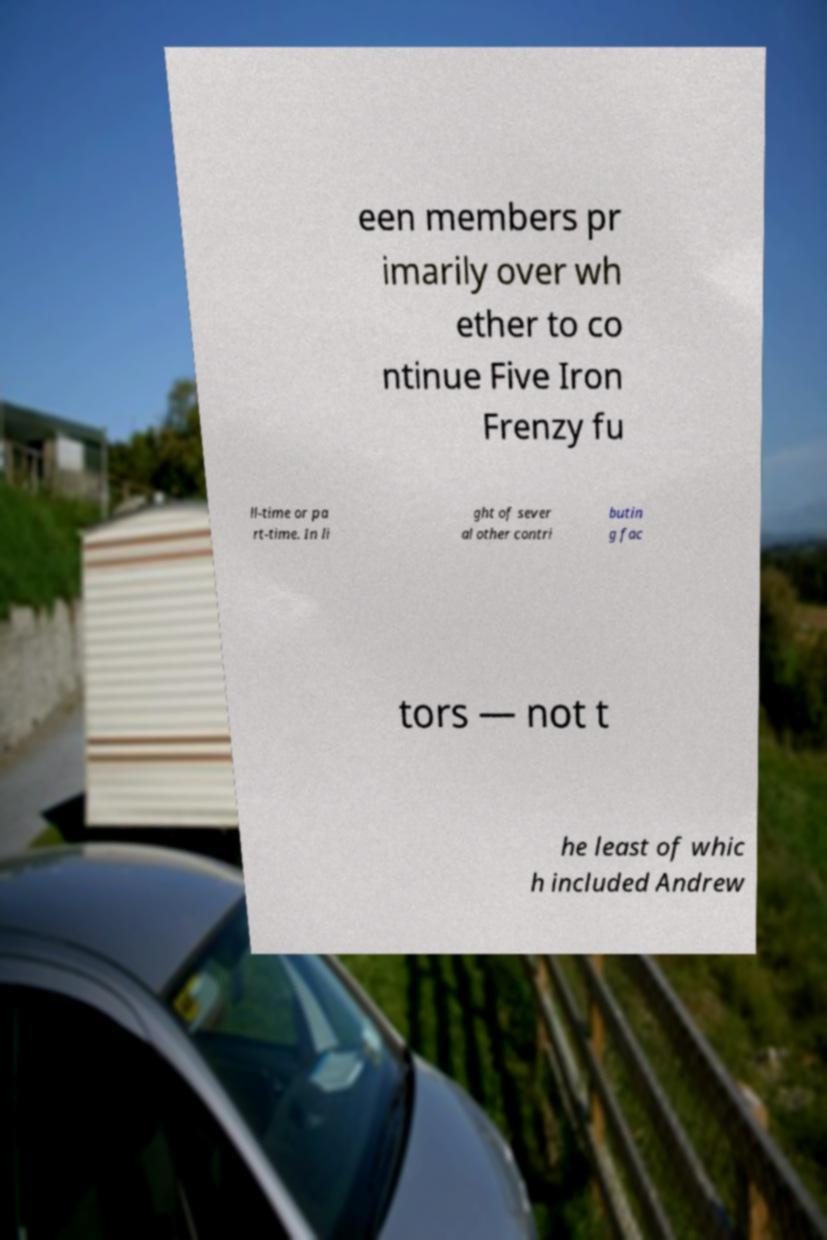What messages or text are displayed in this image? I need them in a readable, typed format. een members pr imarily over wh ether to co ntinue Five Iron Frenzy fu ll-time or pa rt-time. In li ght of sever al other contri butin g fac tors — not t he least of whic h included Andrew 